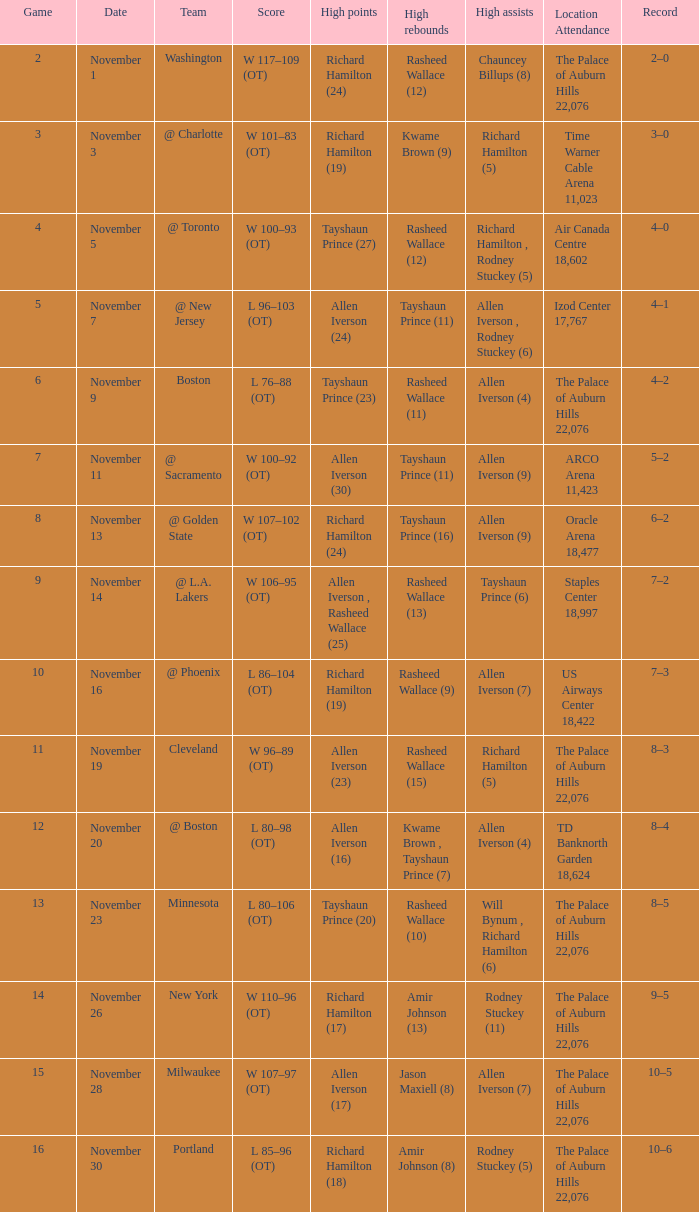What is the maximum score when the game is set to "5"? Allen Iverson (24). 